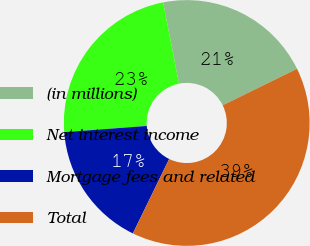<chart> <loc_0><loc_0><loc_500><loc_500><pie_chart><fcel>(in millions)<fcel>Net interest income<fcel>Mortgage fees and related<fcel>Total<nl><fcel>20.82%<fcel>23.11%<fcel>16.59%<fcel>39.49%<nl></chart> 